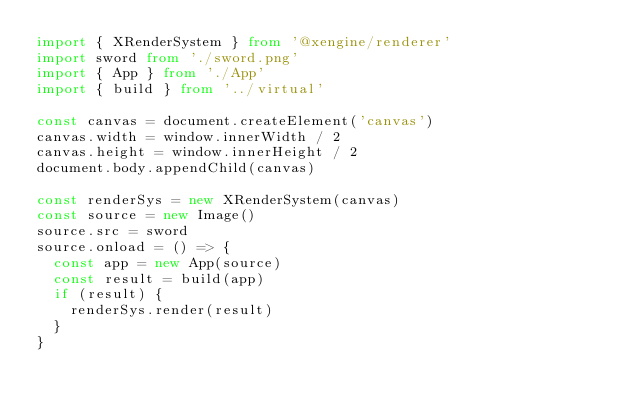<code> <loc_0><loc_0><loc_500><loc_500><_TypeScript_>import { XRenderSystem } from '@xengine/renderer'
import sword from './sword.png'
import { App } from './App'
import { build } from '../virtual'

const canvas = document.createElement('canvas')
canvas.width = window.innerWidth / 2
canvas.height = window.innerHeight / 2
document.body.appendChild(canvas)

const renderSys = new XRenderSystem(canvas)
const source = new Image()
source.src = sword
source.onload = () => {
  const app = new App(source)
  const result = build(app)
  if (result) {
    renderSys.render(result)
  }
}
</code> 